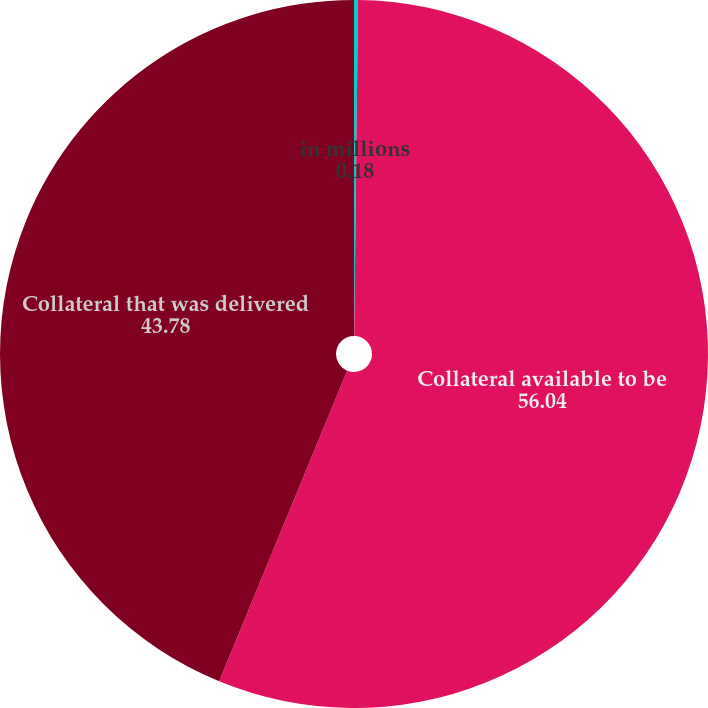<chart> <loc_0><loc_0><loc_500><loc_500><pie_chart><fcel>in millions<fcel>Collateral available to be<fcel>Collateral that was delivered<nl><fcel>0.18%<fcel>56.04%<fcel>43.78%<nl></chart> 